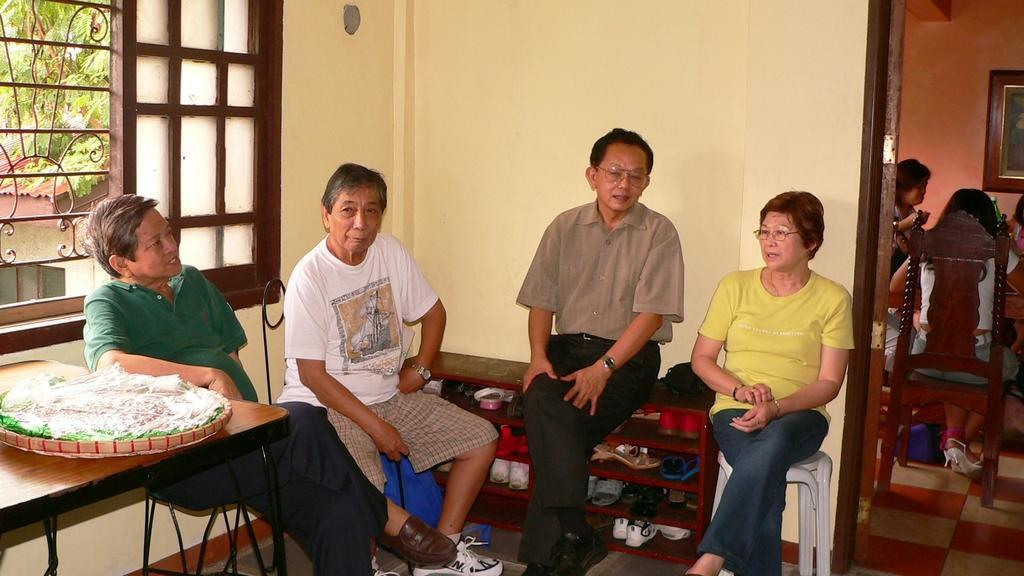Please provide a concise description of this image. As we can see in the image there is wall, window, tables, chairs, few people sitting here and there, photo frame and footwear's. Outside the window there is a house and tree. 